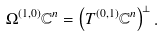<formula> <loc_0><loc_0><loc_500><loc_500>\Omega ^ { ( 1 , 0 ) } \mathbb { C } ^ { n } = \left ( T ^ { ( 0 , 1 ) } \mathbb { C } ^ { n } \right ) ^ { \bot } .</formula> 